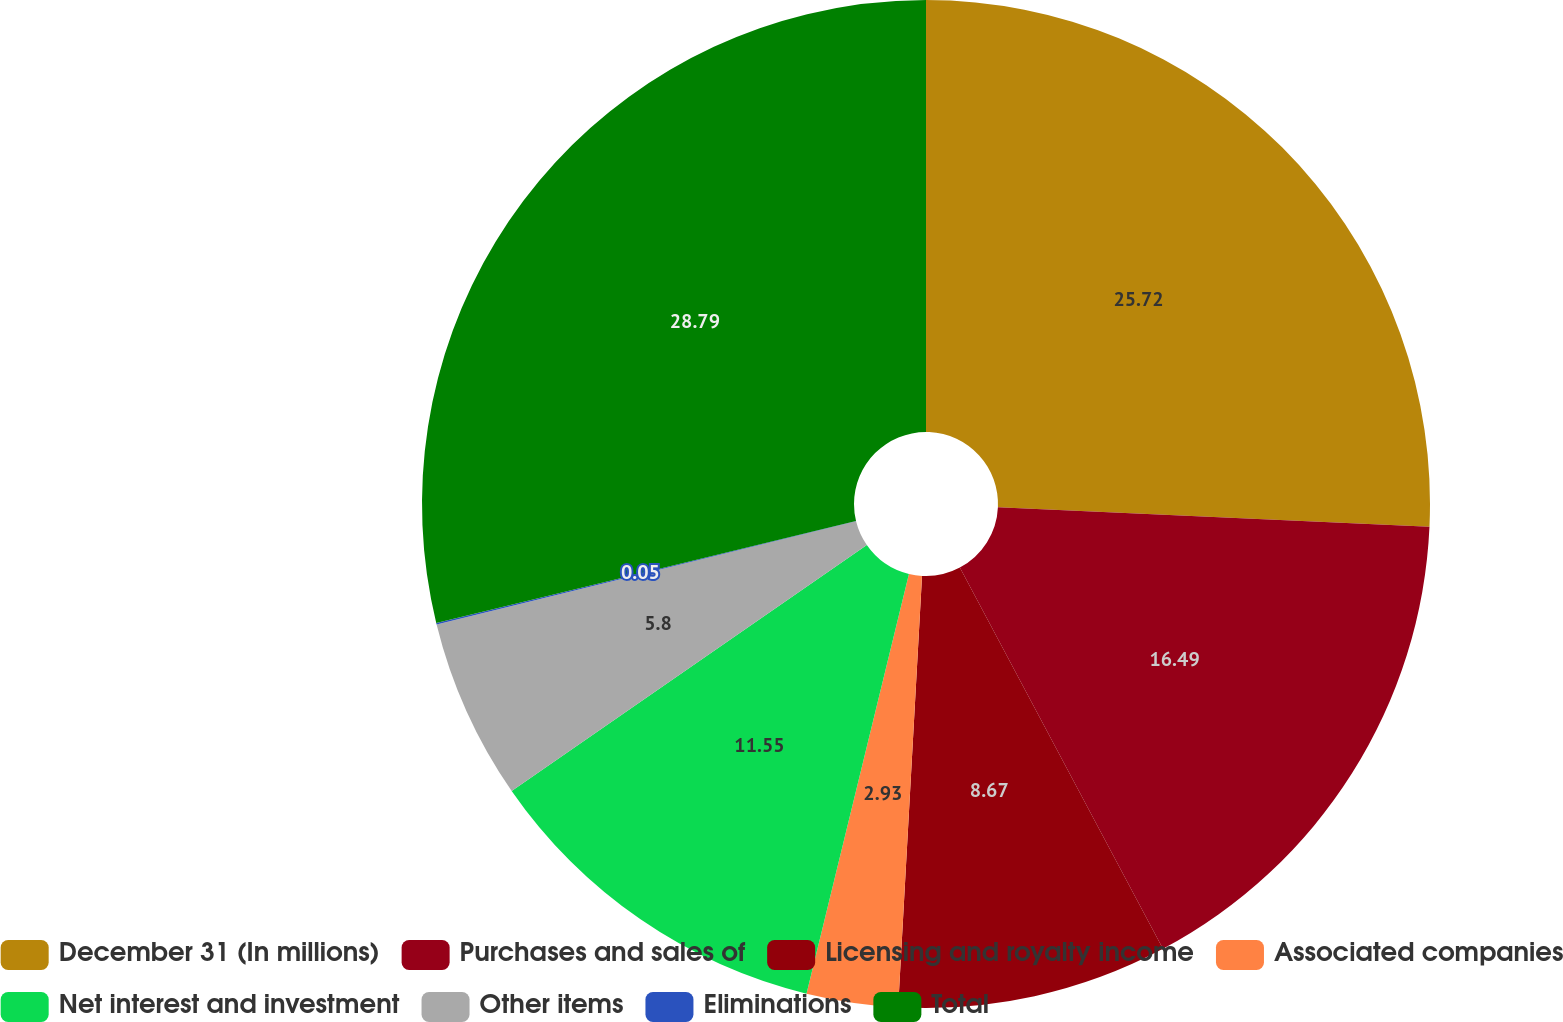<chart> <loc_0><loc_0><loc_500><loc_500><pie_chart><fcel>December 31 (In millions)<fcel>Purchases and sales of<fcel>Licensing and royalty income<fcel>Associated companies<fcel>Net interest and investment<fcel>Other items<fcel>Eliminations<fcel>Total<nl><fcel>25.72%<fcel>16.49%<fcel>8.67%<fcel>2.93%<fcel>11.55%<fcel>5.8%<fcel>0.05%<fcel>28.79%<nl></chart> 